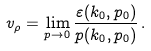Convert formula to latex. <formula><loc_0><loc_0><loc_500><loc_500>v _ { \rho } = \lim _ { p \rightarrow 0 } \frac { \varepsilon ( k _ { 0 } , p _ { 0 } ) } { p ( k _ { 0 } , p _ { 0 } ) } \, .</formula> 